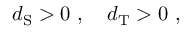Convert formula to latex. <formula><loc_0><loc_0><loc_500><loc_500>d _ { S } > 0 \ , \quad d _ { T } > 0 \ ,</formula> 